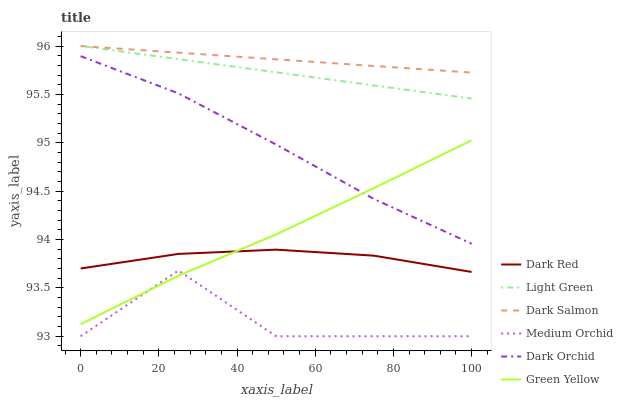Does Medium Orchid have the minimum area under the curve?
Answer yes or no. Yes. Does Dark Salmon have the maximum area under the curve?
Answer yes or no. Yes. Does Dark Salmon have the minimum area under the curve?
Answer yes or no. No. Does Medium Orchid have the maximum area under the curve?
Answer yes or no. No. Is Light Green the smoothest?
Answer yes or no. Yes. Is Medium Orchid the roughest?
Answer yes or no. Yes. Is Dark Salmon the smoothest?
Answer yes or no. No. Is Dark Salmon the roughest?
Answer yes or no. No. Does Medium Orchid have the lowest value?
Answer yes or no. Yes. Does Dark Salmon have the lowest value?
Answer yes or no. No. Does Light Green have the highest value?
Answer yes or no. Yes. Does Medium Orchid have the highest value?
Answer yes or no. No. Is Dark Red less than Dark Orchid?
Answer yes or no. Yes. Is Light Green greater than Medium Orchid?
Answer yes or no. Yes. Does Green Yellow intersect Medium Orchid?
Answer yes or no. Yes. Is Green Yellow less than Medium Orchid?
Answer yes or no. No. Is Green Yellow greater than Medium Orchid?
Answer yes or no. No. Does Dark Red intersect Dark Orchid?
Answer yes or no. No. 